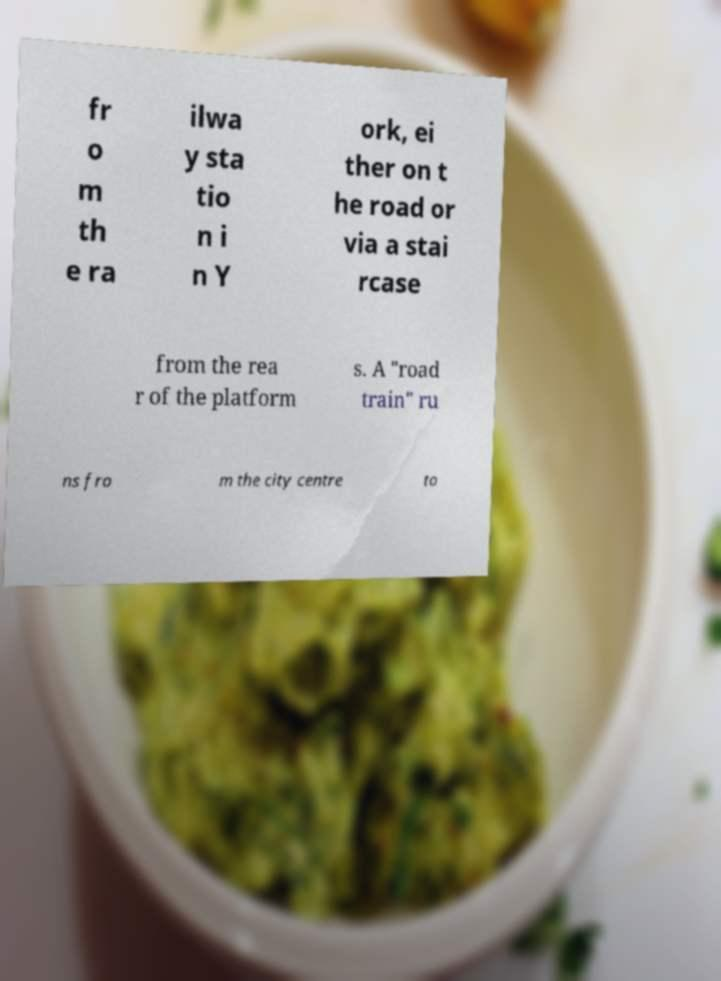Please read and relay the text visible in this image. What does it say? fr o m th e ra ilwa y sta tio n i n Y ork, ei ther on t he road or via a stai rcase from the rea r of the platform s. A "road train" ru ns fro m the city centre to 